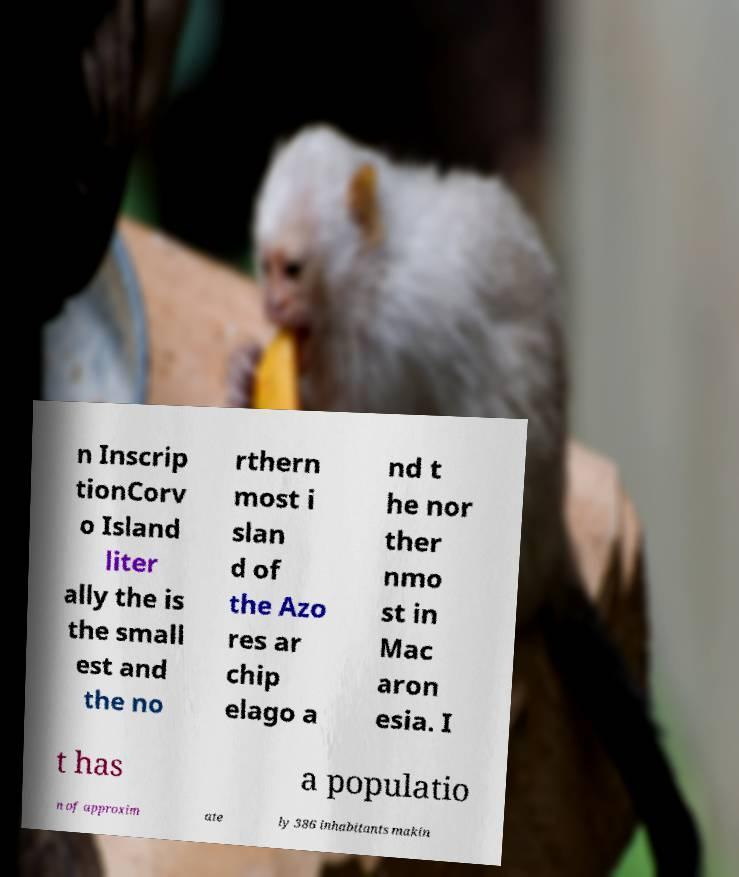I need the written content from this picture converted into text. Can you do that? n Inscrip tionCorv o Island liter ally the is the small est and the no rthern most i slan d of the Azo res ar chip elago a nd t he nor ther nmo st in Mac aron esia. I t has a populatio n of approxim ate ly 386 inhabitants makin 